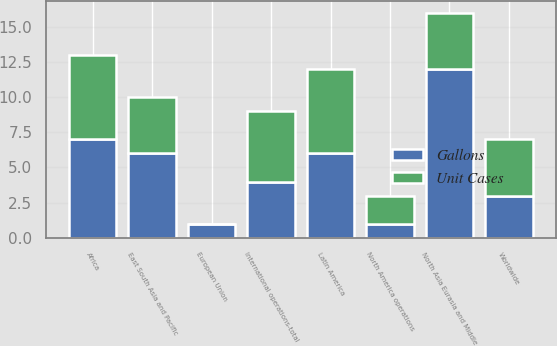<chart> <loc_0><loc_0><loc_500><loc_500><stacked_bar_chart><ecel><fcel>Worldwide<fcel>North America operations<fcel>International operations-total<fcel>Africa<fcel>East South Asia and Pacific<fcel>European Union<fcel>Latin America<fcel>North Asia Eurasia and Middle<nl><fcel>Unit Cases<fcel>4<fcel>2<fcel>5<fcel>6<fcel>4<fcel>0<fcel>6<fcel>4<nl><fcel>Gallons<fcel>3<fcel>1<fcel>4<fcel>7<fcel>6<fcel>1<fcel>6<fcel>12<nl></chart> 